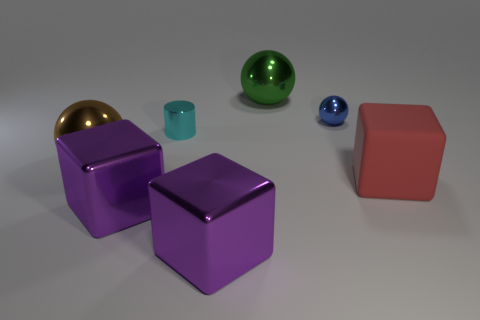Subtract all big purple blocks. How many blocks are left? 1 Add 2 big metal spheres. How many objects exist? 9 Subtract all red cubes. How many cubes are left? 2 Subtract all blocks. How many objects are left? 4 Subtract 0 yellow cylinders. How many objects are left? 7 Subtract all red blocks. Subtract all gray spheres. How many blocks are left? 2 Subtract all gray balls. How many red cubes are left? 1 Subtract all tiny cyan metallic things. Subtract all large green metallic spheres. How many objects are left? 5 Add 2 cubes. How many cubes are left? 5 Add 3 cubes. How many cubes exist? 6 